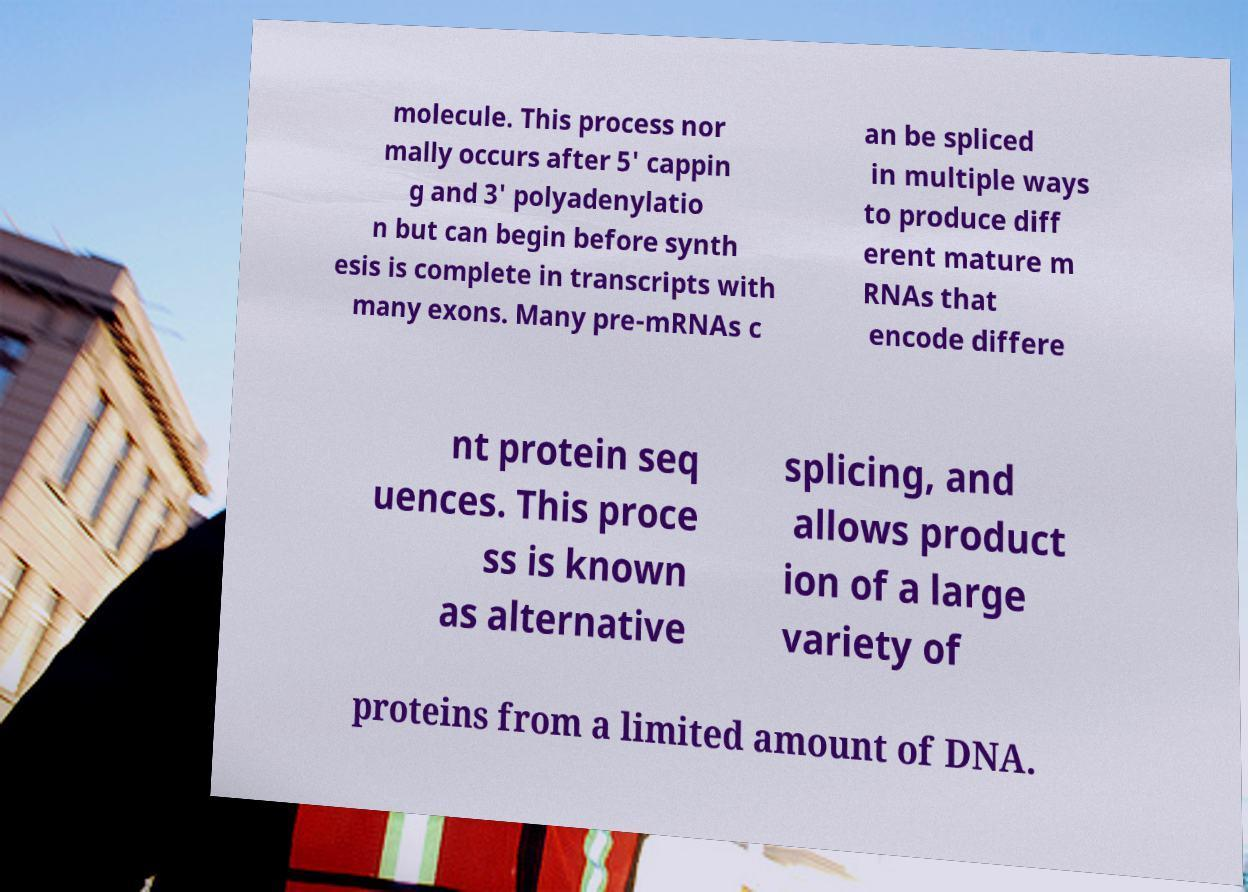Can you read and provide the text displayed in the image?This photo seems to have some interesting text. Can you extract and type it out for me? molecule. This process nor mally occurs after 5' cappin g and 3' polyadenylatio n but can begin before synth esis is complete in transcripts with many exons. Many pre-mRNAs c an be spliced in multiple ways to produce diff erent mature m RNAs that encode differe nt protein seq uences. This proce ss is known as alternative splicing, and allows product ion of a large variety of proteins from a limited amount of DNA. 